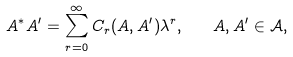<formula> <loc_0><loc_0><loc_500><loc_500>A ^ { * } A ^ { \prime } = \sum _ { r = 0 } ^ { \infty } C _ { r } ( A , A ^ { \prime } ) \lambda ^ { r } , \quad A , A ^ { \prime } \in \mathcal { A } ,</formula> 